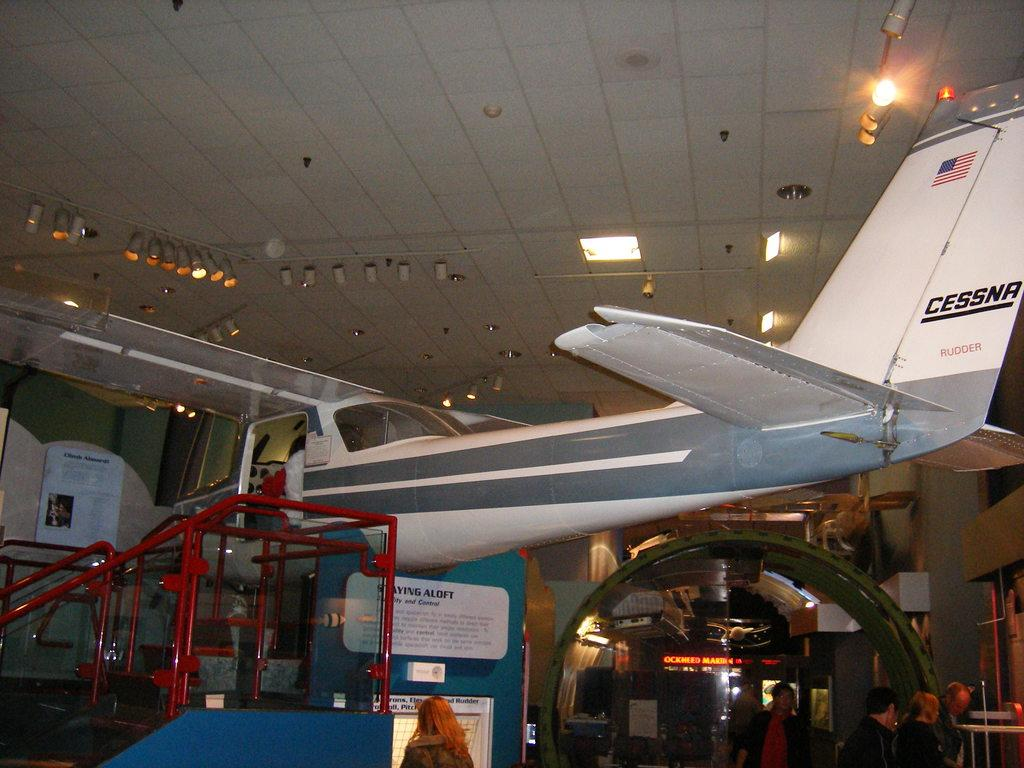Provide a one-sentence caption for the provided image. A white Cessna Rudder plane inside a museum on display. 